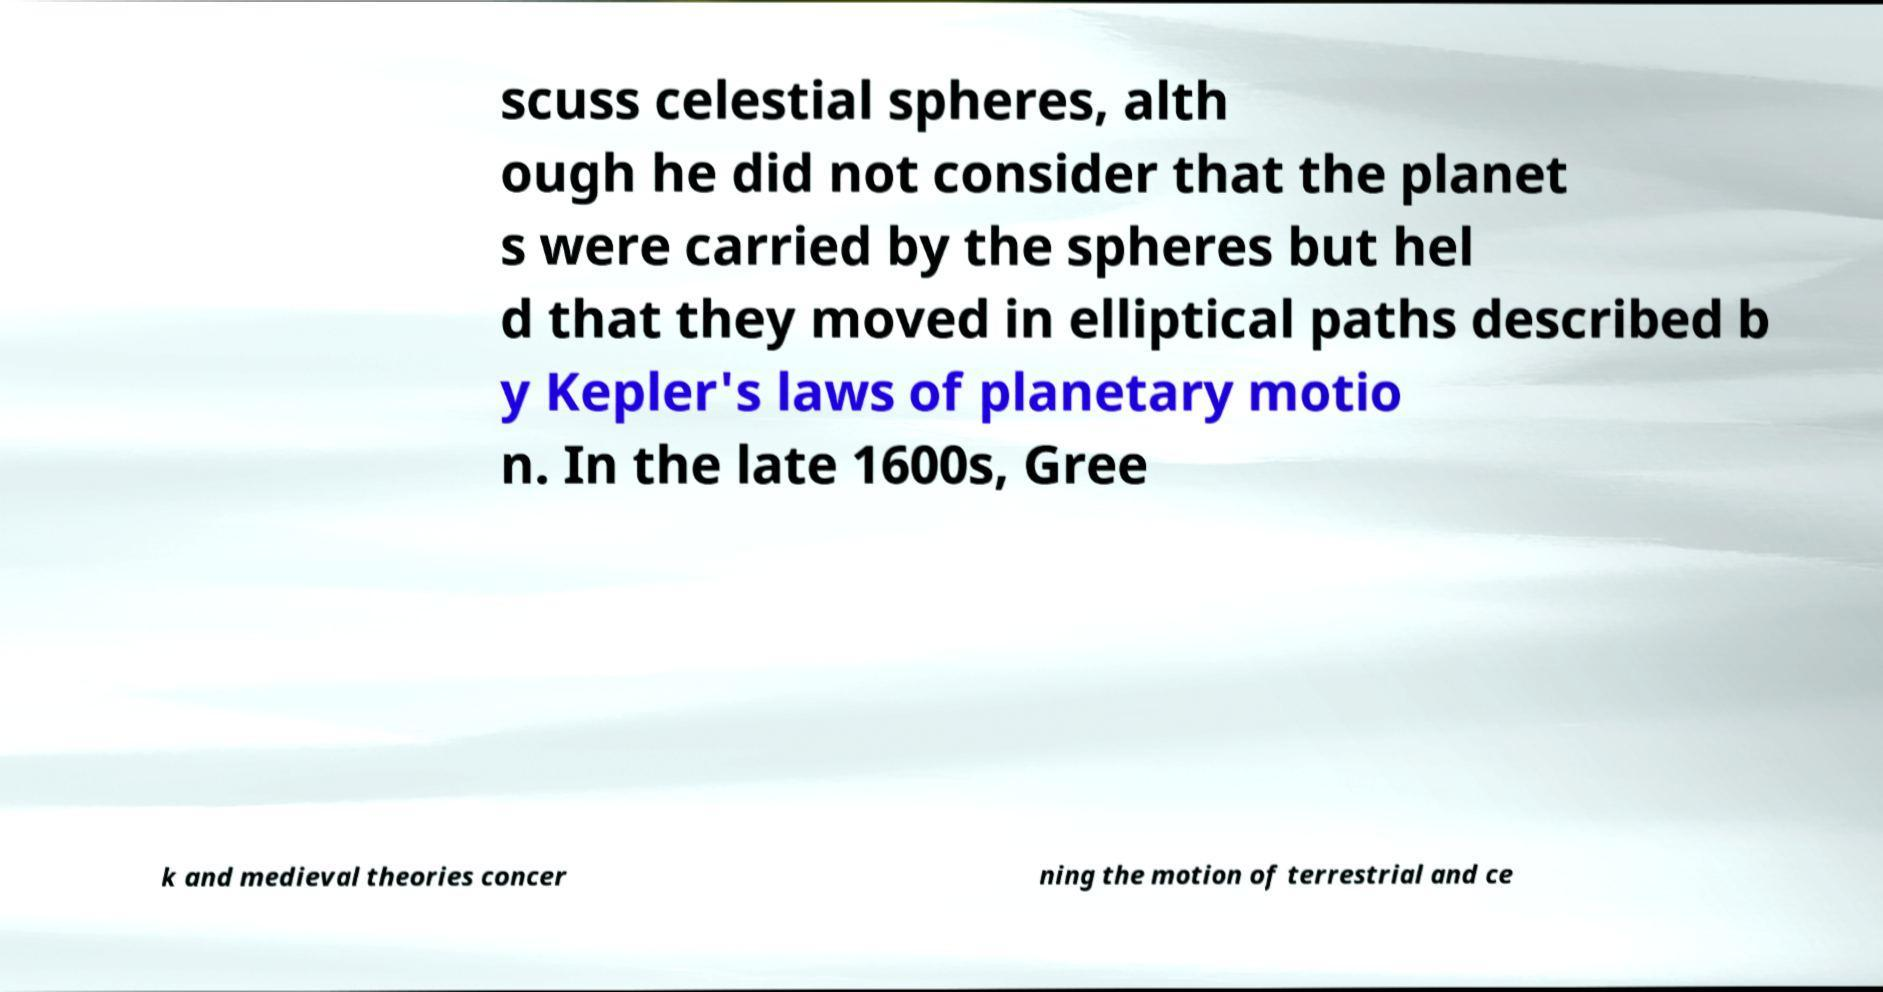What messages or text are displayed in this image? I need them in a readable, typed format. scuss celestial spheres, alth ough he did not consider that the planet s were carried by the spheres but hel d that they moved in elliptical paths described b y Kepler's laws of planetary motio n. In the late 1600s, Gree k and medieval theories concer ning the motion of terrestrial and ce 